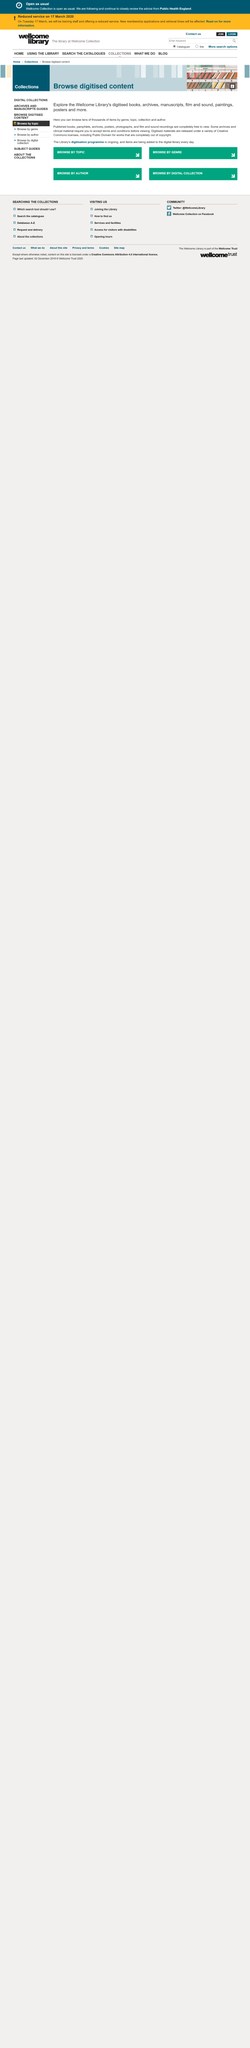Draw attention to some important aspects in this diagram. Photographs are completely free to view. The website allows for browsing of film and sound recordings. Before viewing certain archives and clinical materials, it is necessary to accept the terms and conditions set forth by the material provider. 